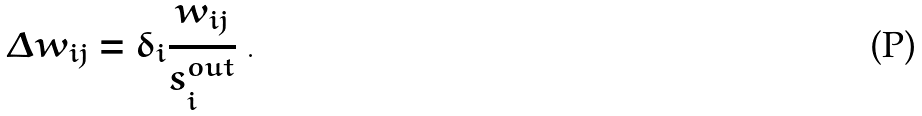<formula> <loc_0><loc_0><loc_500><loc_500>\Delta w _ { i j } = \delta _ { i } \frac { w _ { i j } } { s _ { i } ^ { o u t } } \ .</formula> 